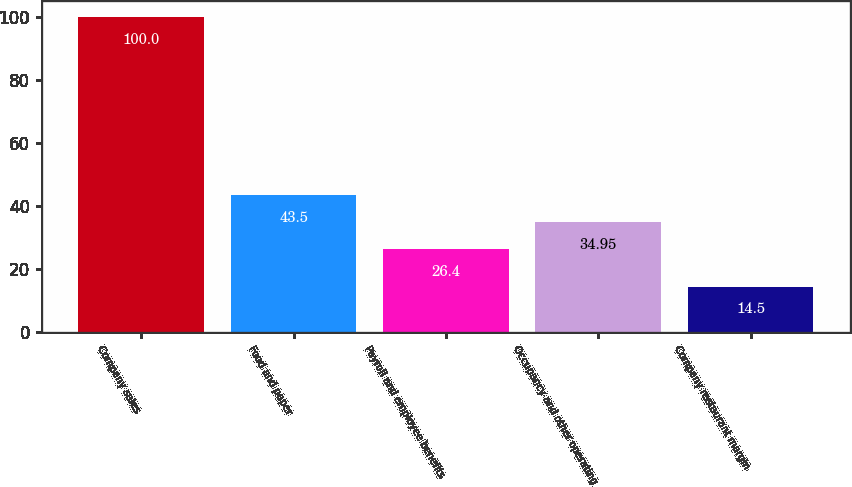Convert chart. <chart><loc_0><loc_0><loc_500><loc_500><bar_chart><fcel>Company sales<fcel>Food and paper<fcel>Payroll and employee benefits<fcel>Occupancy and other operating<fcel>Company restaurant margin<nl><fcel>100<fcel>43.5<fcel>26.4<fcel>34.95<fcel>14.5<nl></chart> 